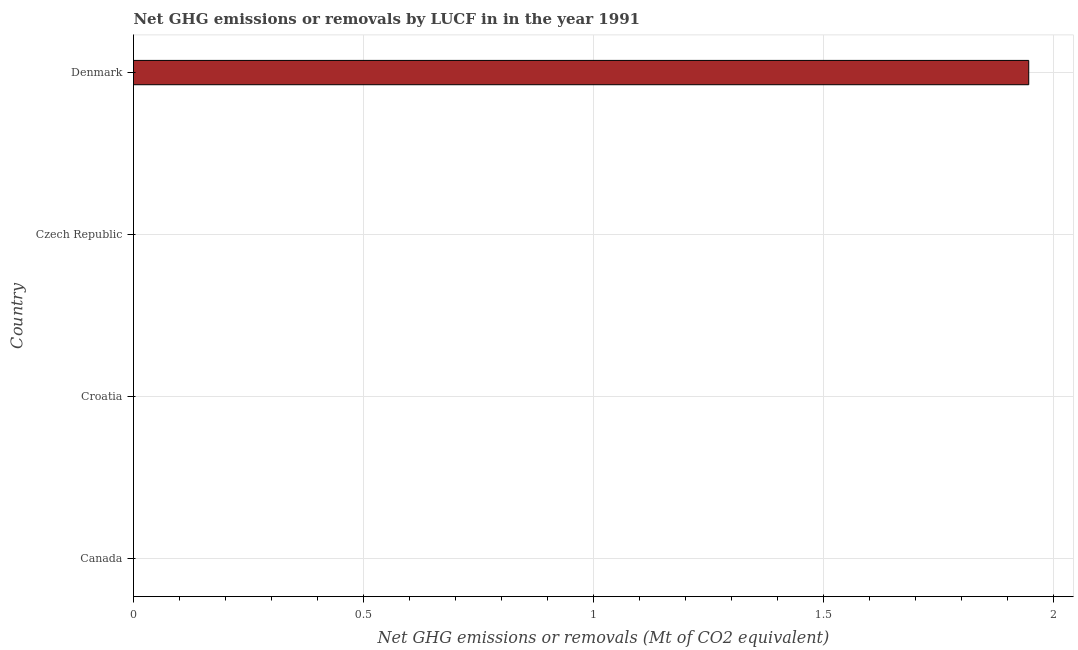Does the graph contain any zero values?
Make the answer very short. Yes. What is the title of the graph?
Ensure brevity in your answer.  Net GHG emissions or removals by LUCF in in the year 1991. What is the label or title of the X-axis?
Your response must be concise. Net GHG emissions or removals (Mt of CO2 equivalent). What is the ghg net emissions or removals in Denmark?
Your answer should be compact. 1.95. Across all countries, what is the maximum ghg net emissions or removals?
Provide a short and direct response. 1.95. Across all countries, what is the minimum ghg net emissions or removals?
Make the answer very short. 0. In which country was the ghg net emissions or removals maximum?
Provide a succinct answer. Denmark. What is the sum of the ghg net emissions or removals?
Ensure brevity in your answer.  1.95. What is the average ghg net emissions or removals per country?
Your response must be concise. 0.49. What is the difference between the highest and the lowest ghg net emissions or removals?
Your response must be concise. 1.95. In how many countries, is the ghg net emissions or removals greater than the average ghg net emissions or removals taken over all countries?
Ensure brevity in your answer.  1. How many bars are there?
Your response must be concise. 1. How many countries are there in the graph?
Offer a very short reply. 4. Are the values on the major ticks of X-axis written in scientific E-notation?
Your answer should be very brief. No. What is the Net GHG emissions or removals (Mt of CO2 equivalent) in Canada?
Your answer should be very brief. 0. What is the Net GHG emissions or removals (Mt of CO2 equivalent) in Croatia?
Give a very brief answer. 0. What is the Net GHG emissions or removals (Mt of CO2 equivalent) of Denmark?
Keep it short and to the point. 1.95. 